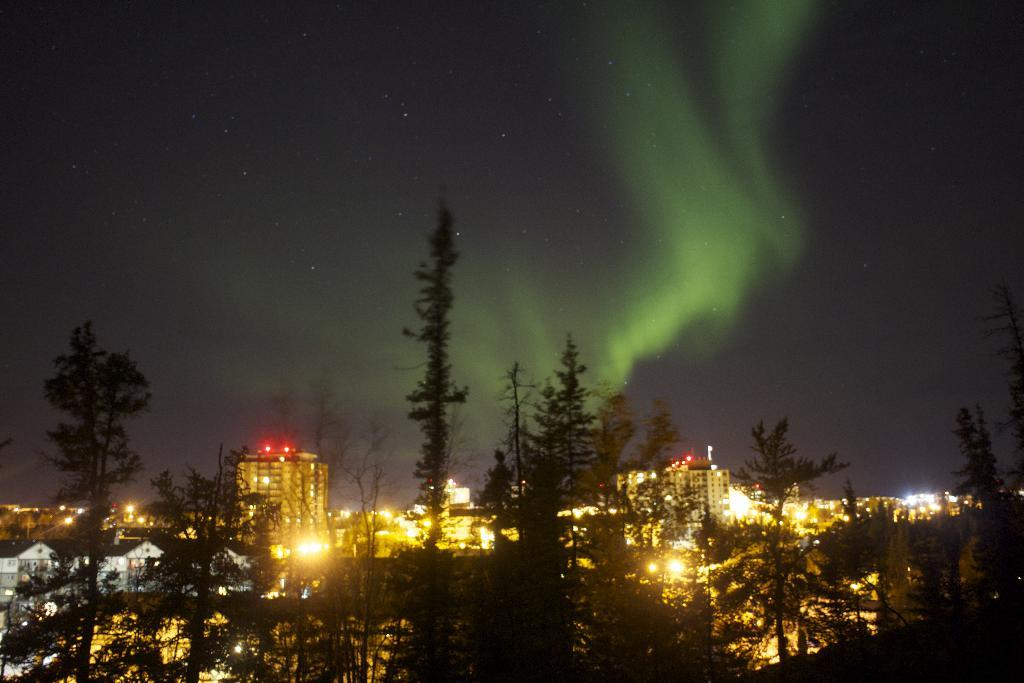What type of structures can be seen in the image? There are buildings in the image. What type of vegetation is present in the image? There are trees with green color in the image. What can be seen in the background of the image? There are lights visible in the background. How would you describe the color of the sky in the image? The sky has a gray color in the image. Where can someone get a haircut in the image? There is no indication of a hair salon or barber shop in the image, so it cannot be determined where someone might get a haircut. 